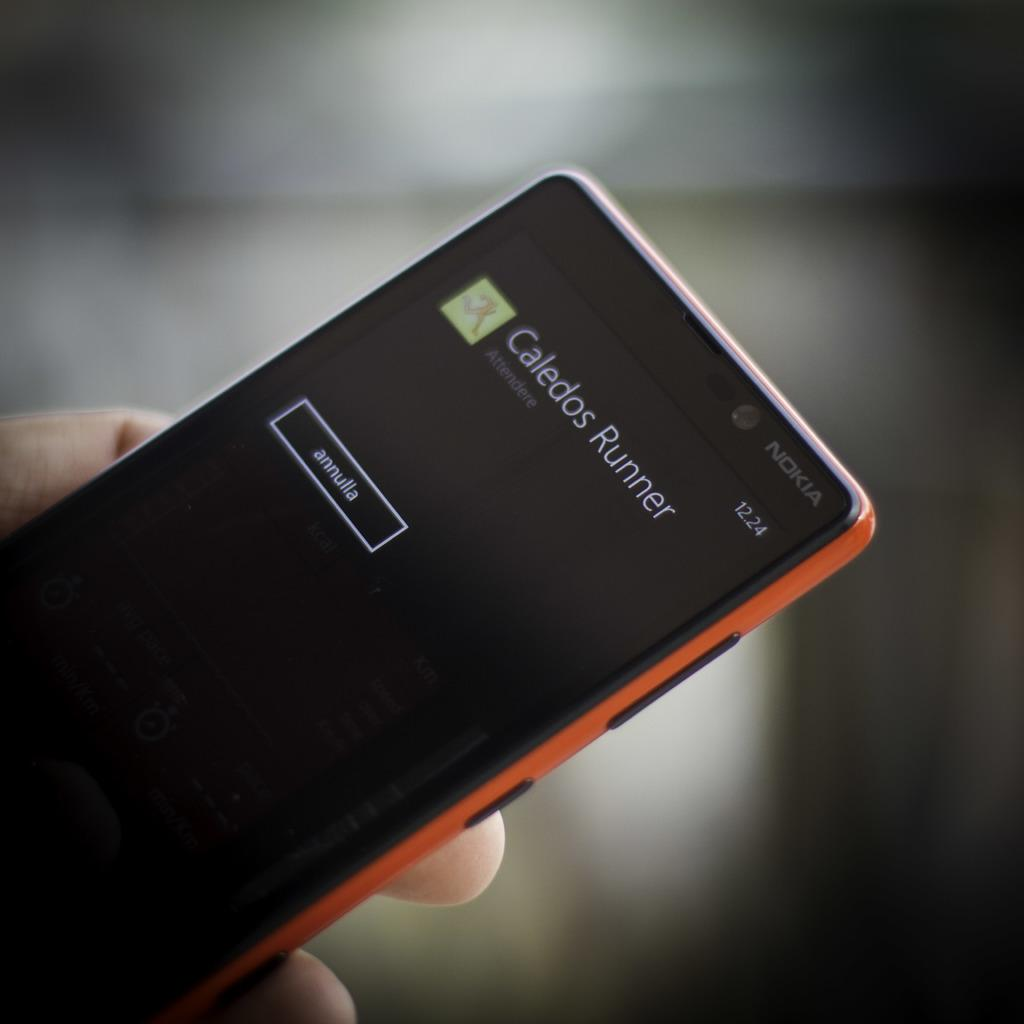Who is present in the image? There is a person in the image. What is the person holding in the image? The person is holding a mobile in the image. Where is the mobile located in relation to the person? The mobile is on the left side of the image. What can be seen on the screen of the mobile? There is text visible on the screen of the mobile. Can you see any sea creatures swimming near the person in the image? There is no sea or sea creatures present in the image. What type of carriage is being used by the person in the image? There is no carriage visible in the image; the person is holding a mobile. 